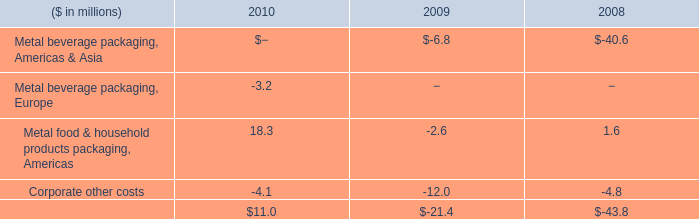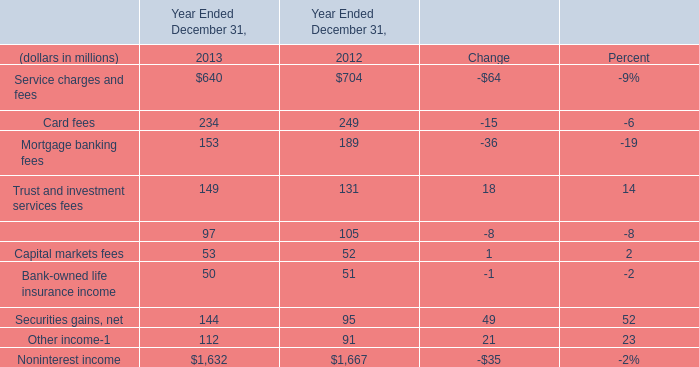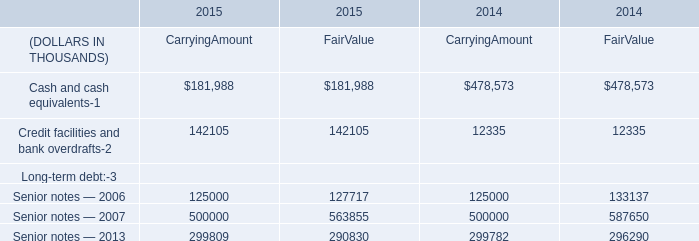What's the sum of the pension plans in U.S. plans in the years where benefits earned during the year in Non-US pension plans is greater than 155? (in million) 
Computations: (((((6 + 581) - 893) + 1) + 148) + 14)
Answer: -143.0. 